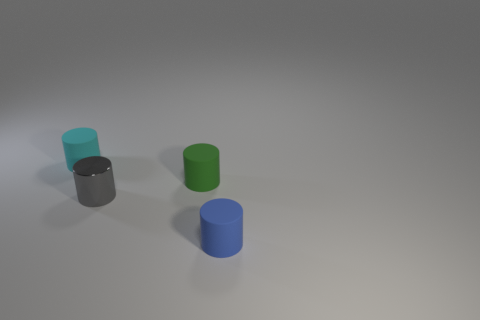Considering the perspective, what can we say about the relative sizes and distances of the cylinders? The cylinders appear to be of similar size, but due to the perspective, objects closer to the viewer look larger. The blue cylinder appears larger and is likely closest to us, while the black cylinder, which looks the smallest, is probably the farthest. The spacing also suggests they are not equidistant from each other. 